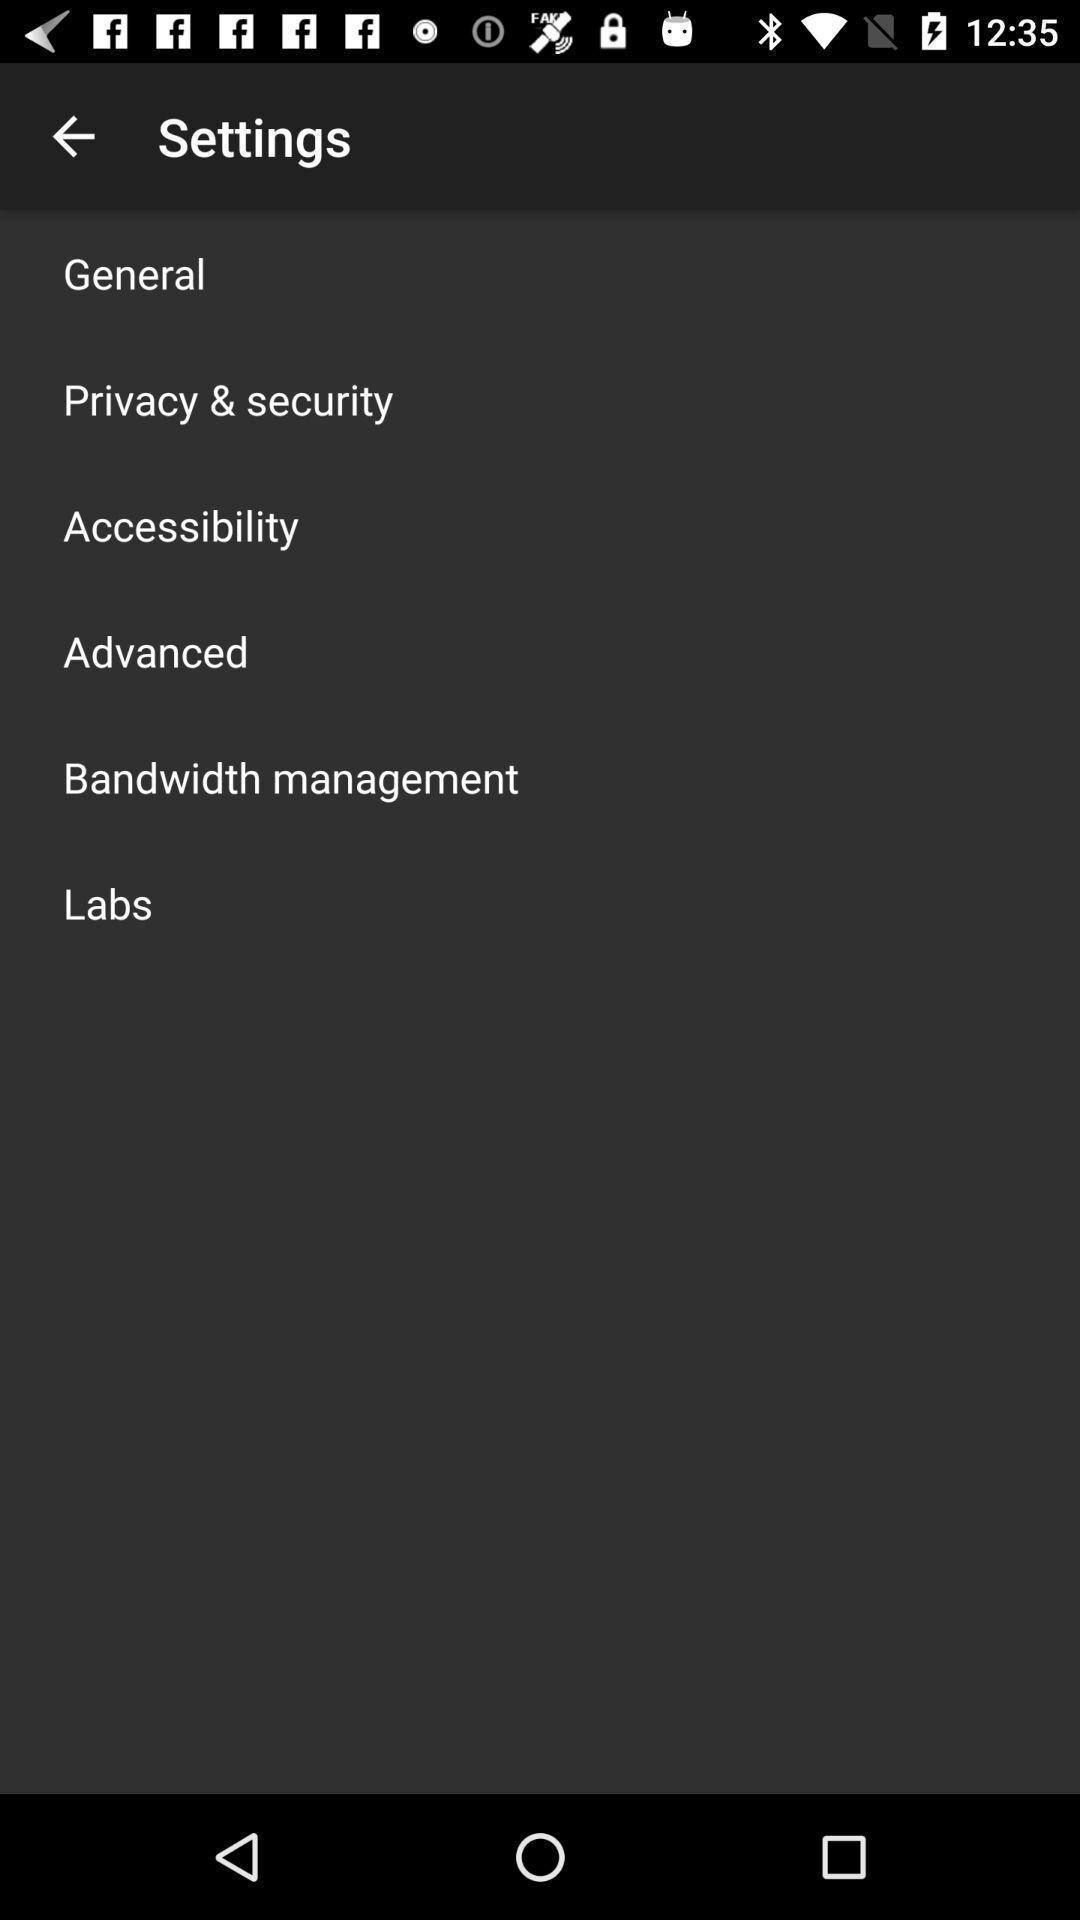Please provide a description for this image. Screen displaying the settings page. 